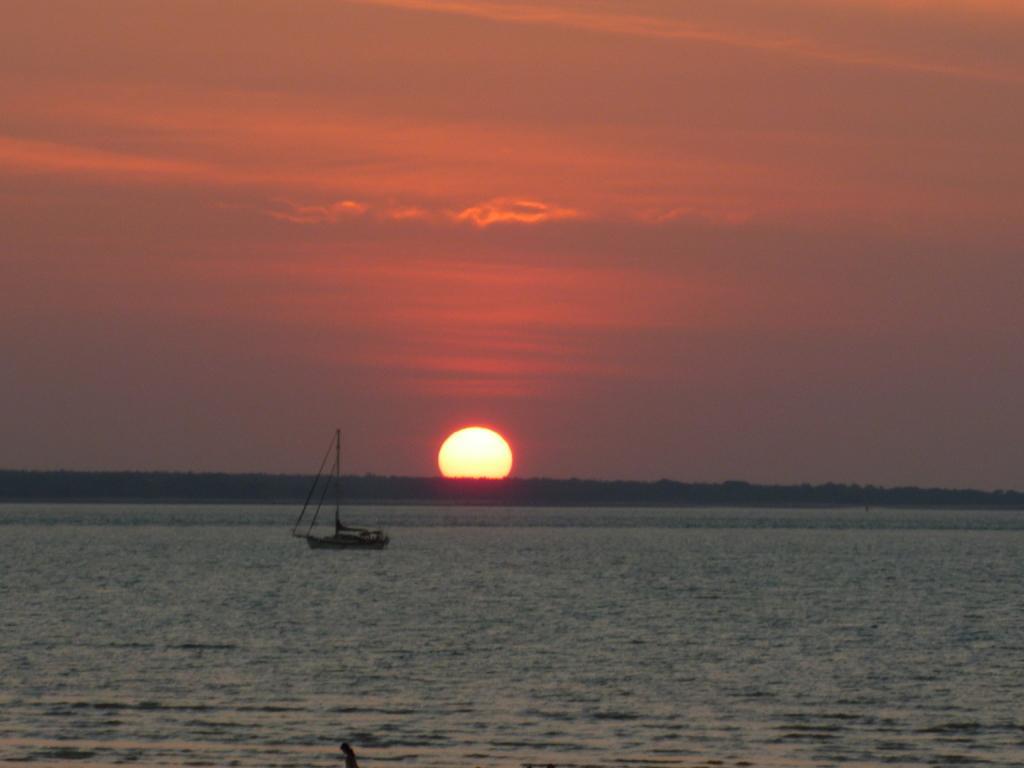Please provide a concise description of this image. In this image I can see a boat on water, background I can see sun and sky is in orange color. 